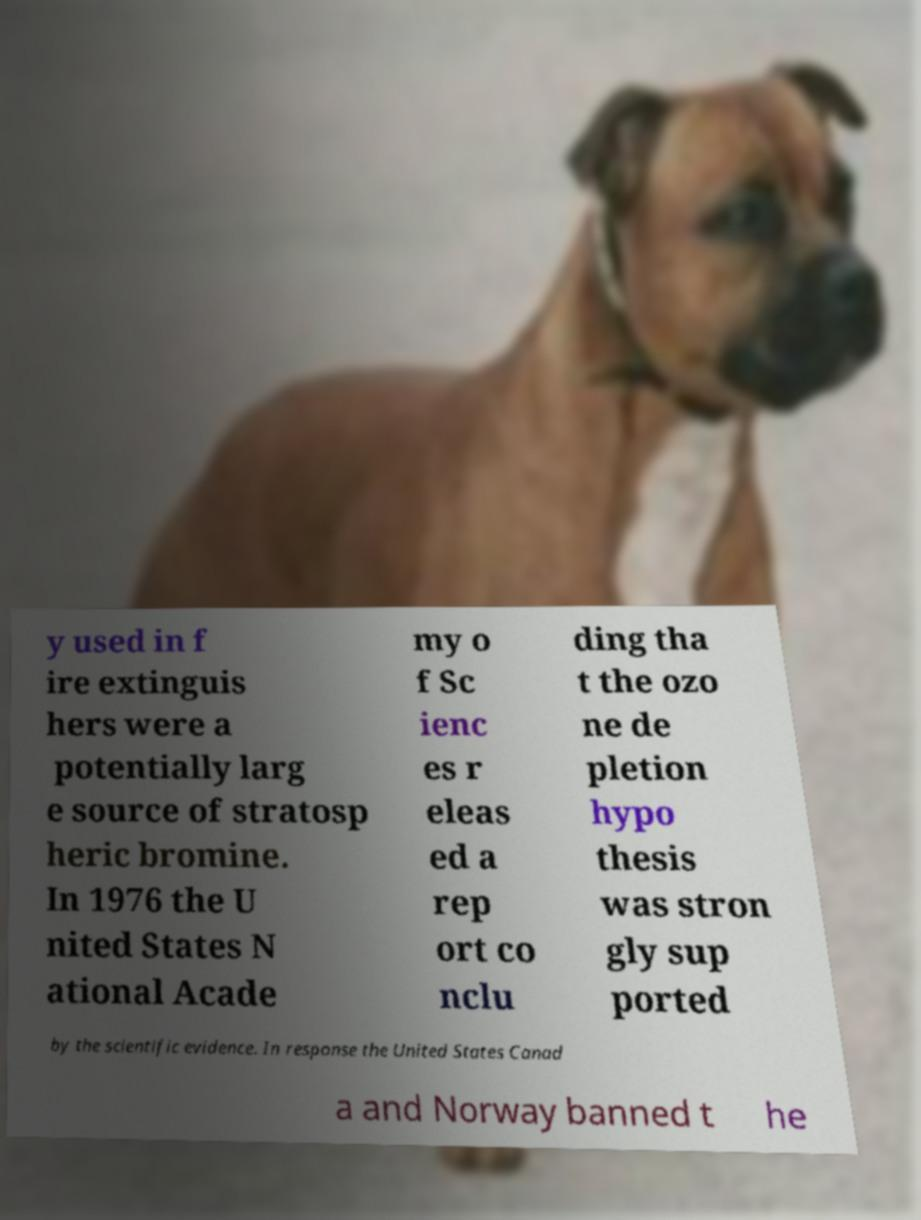Can you read and provide the text displayed in the image?This photo seems to have some interesting text. Can you extract and type it out for me? y used in f ire extinguis hers were a potentially larg e source of stratosp heric bromine. In 1976 the U nited States N ational Acade my o f Sc ienc es r eleas ed a rep ort co nclu ding tha t the ozo ne de pletion hypo thesis was stron gly sup ported by the scientific evidence. In response the United States Canad a and Norway banned t he 